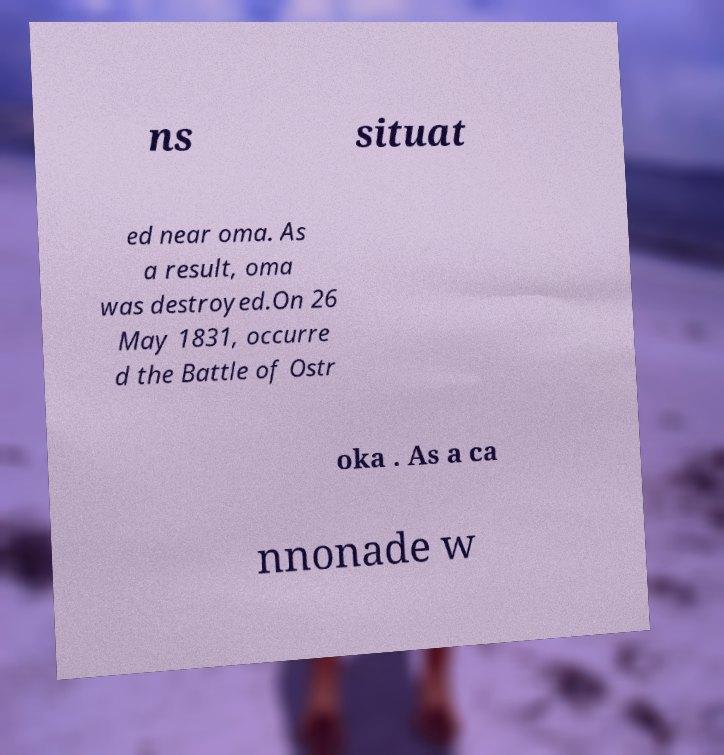Can you read and provide the text displayed in the image?This photo seems to have some interesting text. Can you extract and type it out for me? ns situat ed near oma. As a result, oma was destroyed.On 26 May 1831, occurre d the Battle of Ostr oka . As a ca nnonade w 